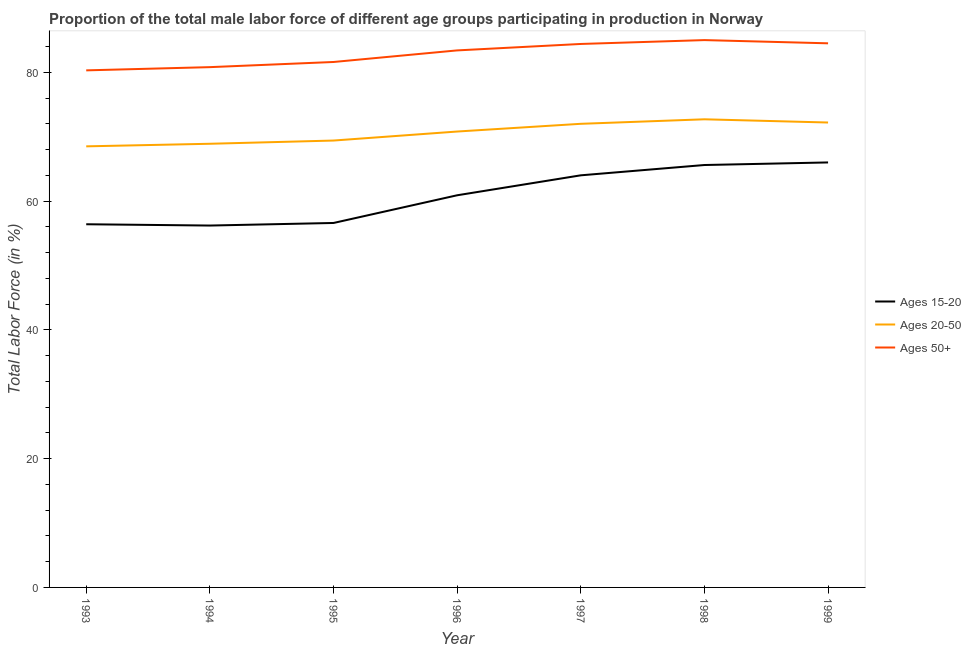How many different coloured lines are there?
Your response must be concise. 3. What is the percentage of male labor force within the age group 15-20 in 1997?
Your response must be concise. 64. Across all years, what is the maximum percentage of male labor force within the age group 20-50?
Your answer should be very brief. 72.7. Across all years, what is the minimum percentage of male labor force within the age group 15-20?
Your answer should be very brief. 56.2. In which year was the percentage of male labor force within the age group 20-50 maximum?
Give a very brief answer. 1998. What is the total percentage of male labor force within the age group 15-20 in the graph?
Keep it short and to the point. 425.7. What is the difference between the percentage of male labor force above age 50 in 1998 and that in 1999?
Offer a very short reply. 0.5. What is the difference between the percentage of male labor force above age 50 in 1993 and the percentage of male labor force within the age group 20-50 in 1998?
Keep it short and to the point. 7.6. What is the average percentage of male labor force within the age group 15-20 per year?
Make the answer very short. 60.81. In the year 1993, what is the difference between the percentage of male labor force within the age group 15-20 and percentage of male labor force within the age group 20-50?
Keep it short and to the point. -12.1. In how many years, is the percentage of male labor force within the age group 15-20 greater than 40 %?
Offer a very short reply. 7. What is the ratio of the percentage of male labor force above age 50 in 1996 to that in 1998?
Your answer should be very brief. 0.98. Is the percentage of male labor force within the age group 20-50 in 1994 less than that in 1996?
Your response must be concise. Yes. What is the difference between the highest and the second highest percentage of male labor force within the age group 20-50?
Your answer should be very brief. 0.5. What is the difference between the highest and the lowest percentage of male labor force within the age group 20-50?
Make the answer very short. 4.2. In how many years, is the percentage of male labor force within the age group 15-20 greater than the average percentage of male labor force within the age group 15-20 taken over all years?
Your answer should be compact. 4. Is the sum of the percentage of male labor force above age 50 in 1997 and 1998 greater than the maximum percentage of male labor force within the age group 20-50 across all years?
Your answer should be very brief. Yes. Is it the case that in every year, the sum of the percentage of male labor force within the age group 15-20 and percentage of male labor force within the age group 20-50 is greater than the percentage of male labor force above age 50?
Offer a terse response. Yes. What is the difference between two consecutive major ticks on the Y-axis?
Offer a terse response. 20. Does the graph contain any zero values?
Your answer should be compact. No. What is the title of the graph?
Your answer should be very brief. Proportion of the total male labor force of different age groups participating in production in Norway. Does "Machinery" appear as one of the legend labels in the graph?
Make the answer very short. No. What is the label or title of the X-axis?
Your answer should be very brief. Year. What is the Total Labor Force (in %) in Ages 15-20 in 1993?
Ensure brevity in your answer.  56.4. What is the Total Labor Force (in %) of Ages 20-50 in 1993?
Keep it short and to the point. 68.5. What is the Total Labor Force (in %) in Ages 50+ in 1993?
Offer a terse response. 80.3. What is the Total Labor Force (in %) of Ages 15-20 in 1994?
Provide a short and direct response. 56.2. What is the Total Labor Force (in %) of Ages 20-50 in 1994?
Keep it short and to the point. 68.9. What is the Total Labor Force (in %) in Ages 50+ in 1994?
Give a very brief answer. 80.8. What is the Total Labor Force (in %) in Ages 15-20 in 1995?
Keep it short and to the point. 56.6. What is the Total Labor Force (in %) in Ages 20-50 in 1995?
Your answer should be compact. 69.4. What is the Total Labor Force (in %) in Ages 50+ in 1995?
Offer a very short reply. 81.6. What is the Total Labor Force (in %) of Ages 15-20 in 1996?
Make the answer very short. 60.9. What is the Total Labor Force (in %) of Ages 20-50 in 1996?
Offer a terse response. 70.8. What is the Total Labor Force (in %) in Ages 50+ in 1996?
Offer a terse response. 83.4. What is the Total Labor Force (in %) of Ages 15-20 in 1997?
Ensure brevity in your answer.  64. What is the Total Labor Force (in %) of Ages 50+ in 1997?
Offer a terse response. 84.4. What is the Total Labor Force (in %) of Ages 15-20 in 1998?
Make the answer very short. 65.6. What is the Total Labor Force (in %) of Ages 20-50 in 1998?
Your response must be concise. 72.7. What is the Total Labor Force (in %) in Ages 20-50 in 1999?
Provide a short and direct response. 72.2. What is the Total Labor Force (in %) in Ages 50+ in 1999?
Keep it short and to the point. 84.5. Across all years, what is the maximum Total Labor Force (in %) in Ages 20-50?
Provide a short and direct response. 72.7. Across all years, what is the maximum Total Labor Force (in %) of Ages 50+?
Keep it short and to the point. 85. Across all years, what is the minimum Total Labor Force (in %) of Ages 15-20?
Provide a succinct answer. 56.2. Across all years, what is the minimum Total Labor Force (in %) in Ages 20-50?
Give a very brief answer. 68.5. Across all years, what is the minimum Total Labor Force (in %) of Ages 50+?
Your response must be concise. 80.3. What is the total Total Labor Force (in %) of Ages 15-20 in the graph?
Offer a very short reply. 425.7. What is the total Total Labor Force (in %) of Ages 20-50 in the graph?
Your answer should be compact. 494.5. What is the total Total Labor Force (in %) in Ages 50+ in the graph?
Provide a short and direct response. 580. What is the difference between the Total Labor Force (in %) of Ages 50+ in 1993 and that in 1994?
Keep it short and to the point. -0.5. What is the difference between the Total Labor Force (in %) in Ages 20-50 in 1993 and that in 1995?
Your answer should be compact. -0.9. What is the difference between the Total Labor Force (in %) in Ages 15-20 in 1993 and that in 1996?
Your answer should be compact. -4.5. What is the difference between the Total Labor Force (in %) in Ages 20-50 in 1993 and that in 1996?
Ensure brevity in your answer.  -2.3. What is the difference between the Total Labor Force (in %) of Ages 20-50 in 1993 and that in 1997?
Give a very brief answer. -3.5. What is the difference between the Total Labor Force (in %) of Ages 50+ in 1993 and that in 1997?
Provide a succinct answer. -4.1. What is the difference between the Total Labor Force (in %) of Ages 20-50 in 1993 and that in 1998?
Keep it short and to the point. -4.2. What is the difference between the Total Labor Force (in %) in Ages 50+ in 1993 and that in 1998?
Provide a succinct answer. -4.7. What is the difference between the Total Labor Force (in %) of Ages 15-20 in 1993 and that in 1999?
Give a very brief answer. -9.6. What is the difference between the Total Labor Force (in %) of Ages 50+ in 1994 and that in 1995?
Provide a short and direct response. -0.8. What is the difference between the Total Labor Force (in %) of Ages 15-20 in 1994 and that in 1996?
Ensure brevity in your answer.  -4.7. What is the difference between the Total Labor Force (in %) of Ages 20-50 in 1994 and that in 1996?
Give a very brief answer. -1.9. What is the difference between the Total Labor Force (in %) of Ages 50+ in 1994 and that in 1996?
Your answer should be very brief. -2.6. What is the difference between the Total Labor Force (in %) of Ages 15-20 in 1994 and that in 1998?
Provide a short and direct response. -9.4. What is the difference between the Total Labor Force (in %) of Ages 20-50 in 1994 and that in 1998?
Make the answer very short. -3.8. What is the difference between the Total Labor Force (in %) in Ages 15-20 in 1994 and that in 1999?
Make the answer very short. -9.8. What is the difference between the Total Labor Force (in %) in Ages 15-20 in 1995 and that in 1996?
Your answer should be very brief. -4.3. What is the difference between the Total Labor Force (in %) of Ages 50+ in 1995 and that in 1996?
Make the answer very short. -1.8. What is the difference between the Total Labor Force (in %) of Ages 20-50 in 1995 and that in 1997?
Offer a terse response. -2.6. What is the difference between the Total Labor Force (in %) of Ages 50+ in 1995 and that in 1997?
Your answer should be very brief. -2.8. What is the difference between the Total Labor Force (in %) of Ages 15-20 in 1995 and that in 1998?
Provide a short and direct response. -9. What is the difference between the Total Labor Force (in %) of Ages 20-50 in 1995 and that in 1998?
Make the answer very short. -3.3. What is the difference between the Total Labor Force (in %) of Ages 50+ in 1995 and that in 1998?
Your answer should be very brief. -3.4. What is the difference between the Total Labor Force (in %) in Ages 15-20 in 1995 and that in 1999?
Give a very brief answer. -9.4. What is the difference between the Total Labor Force (in %) of Ages 20-50 in 1995 and that in 1999?
Provide a succinct answer. -2.8. What is the difference between the Total Labor Force (in %) of Ages 50+ in 1995 and that in 1999?
Give a very brief answer. -2.9. What is the difference between the Total Labor Force (in %) of Ages 15-20 in 1996 and that in 1997?
Provide a short and direct response. -3.1. What is the difference between the Total Labor Force (in %) of Ages 50+ in 1996 and that in 1997?
Your response must be concise. -1. What is the difference between the Total Labor Force (in %) of Ages 15-20 in 1996 and that in 1998?
Keep it short and to the point. -4.7. What is the difference between the Total Labor Force (in %) in Ages 20-50 in 1996 and that in 1999?
Offer a terse response. -1.4. What is the difference between the Total Labor Force (in %) of Ages 15-20 in 1997 and that in 1998?
Keep it short and to the point. -1.6. What is the difference between the Total Labor Force (in %) in Ages 20-50 in 1997 and that in 1998?
Your response must be concise. -0.7. What is the difference between the Total Labor Force (in %) of Ages 50+ in 1997 and that in 1998?
Offer a very short reply. -0.6. What is the difference between the Total Labor Force (in %) of Ages 50+ in 1997 and that in 1999?
Keep it short and to the point. -0.1. What is the difference between the Total Labor Force (in %) of Ages 20-50 in 1998 and that in 1999?
Offer a terse response. 0.5. What is the difference between the Total Labor Force (in %) in Ages 50+ in 1998 and that in 1999?
Give a very brief answer. 0.5. What is the difference between the Total Labor Force (in %) of Ages 15-20 in 1993 and the Total Labor Force (in %) of Ages 20-50 in 1994?
Your response must be concise. -12.5. What is the difference between the Total Labor Force (in %) in Ages 15-20 in 1993 and the Total Labor Force (in %) in Ages 50+ in 1994?
Offer a very short reply. -24.4. What is the difference between the Total Labor Force (in %) in Ages 15-20 in 1993 and the Total Labor Force (in %) in Ages 20-50 in 1995?
Provide a succinct answer. -13. What is the difference between the Total Labor Force (in %) in Ages 15-20 in 1993 and the Total Labor Force (in %) in Ages 50+ in 1995?
Make the answer very short. -25.2. What is the difference between the Total Labor Force (in %) in Ages 20-50 in 1993 and the Total Labor Force (in %) in Ages 50+ in 1995?
Give a very brief answer. -13.1. What is the difference between the Total Labor Force (in %) in Ages 15-20 in 1993 and the Total Labor Force (in %) in Ages 20-50 in 1996?
Your answer should be very brief. -14.4. What is the difference between the Total Labor Force (in %) in Ages 20-50 in 1993 and the Total Labor Force (in %) in Ages 50+ in 1996?
Your response must be concise. -14.9. What is the difference between the Total Labor Force (in %) of Ages 15-20 in 1993 and the Total Labor Force (in %) of Ages 20-50 in 1997?
Make the answer very short. -15.6. What is the difference between the Total Labor Force (in %) of Ages 15-20 in 1993 and the Total Labor Force (in %) of Ages 50+ in 1997?
Make the answer very short. -28. What is the difference between the Total Labor Force (in %) of Ages 20-50 in 1993 and the Total Labor Force (in %) of Ages 50+ in 1997?
Your answer should be very brief. -15.9. What is the difference between the Total Labor Force (in %) of Ages 15-20 in 1993 and the Total Labor Force (in %) of Ages 20-50 in 1998?
Offer a very short reply. -16.3. What is the difference between the Total Labor Force (in %) of Ages 15-20 in 1993 and the Total Labor Force (in %) of Ages 50+ in 1998?
Ensure brevity in your answer.  -28.6. What is the difference between the Total Labor Force (in %) of Ages 20-50 in 1993 and the Total Labor Force (in %) of Ages 50+ in 1998?
Make the answer very short. -16.5. What is the difference between the Total Labor Force (in %) of Ages 15-20 in 1993 and the Total Labor Force (in %) of Ages 20-50 in 1999?
Offer a very short reply. -15.8. What is the difference between the Total Labor Force (in %) in Ages 15-20 in 1993 and the Total Labor Force (in %) in Ages 50+ in 1999?
Keep it short and to the point. -28.1. What is the difference between the Total Labor Force (in %) of Ages 15-20 in 1994 and the Total Labor Force (in %) of Ages 20-50 in 1995?
Ensure brevity in your answer.  -13.2. What is the difference between the Total Labor Force (in %) of Ages 15-20 in 1994 and the Total Labor Force (in %) of Ages 50+ in 1995?
Provide a short and direct response. -25.4. What is the difference between the Total Labor Force (in %) in Ages 20-50 in 1994 and the Total Labor Force (in %) in Ages 50+ in 1995?
Your answer should be very brief. -12.7. What is the difference between the Total Labor Force (in %) of Ages 15-20 in 1994 and the Total Labor Force (in %) of Ages 20-50 in 1996?
Give a very brief answer. -14.6. What is the difference between the Total Labor Force (in %) in Ages 15-20 in 1994 and the Total Labor Force (in %) in Ages 50+ in 1996?
Offer a very short reply. -27.2. What is the difference between the Total Labor Force (in %) of Ages 20-50 in 1994 and the Total Labor Force (in %) of Ages 50+ in 1996?
Your response must be concise. -14.5. What is the difference between the Total Labor Force (in %) of Ages 15-20 in 1994 and the Total Labor Force (in %) of Ages 20-50 in 1997?
Your answer should be very brief. -15.8. What is the difference between the Total Labor Force (in %) in Ages 15-20 in 1994 and the Total Labor Force (in %) in Ages 50+ in 1997?
Your answer should be very brief. -28.2. What is the difference between the Total Labor Force (in %) in Ages 20-50 in 1994 and the Total Labor Force (in %) in Ages 50+ in 1997?
Keep it short and to the point. -15.5. What is the difference between the Total Labor Force (in %) in Ages 15-20 in 1994 and the Total Labor Force (in %) in Ages 20-50 in 1998?
Ensure brevity in your answer.  -16.5. What is the difference between the Total Labor Force (in %) in Ages 15-20 in 1994 and the Total Labor Force (in %) in Ages 50+ in 1998?
Ensure brevity in your answer.  -28.8. What is the difference between the Total Labor Force (in %) in Ages 20-50 in 1994 and the Total Labor Force (in %) in Ages 50+ in 1998?
Your answer should be compact. -16.1. What is the difference between the Total Labor Force (in %) in Ages 15-20 in 1994 and the Total Labor Force (in %) in Ages 20-50 in 1999?
Make the answer very short. -16. What is the difference between the Total Labor Force (in %) of Ages 15-20 in 1994 and the Total Labor Force (in %) of Ages 50+ in 1999?
Provide a short and direct response. -28.3. What is the difference between the Total Labor Force (in %) in Ages 20-50 in 1994 and the Total Labor Force (in %) in Ages 50+ in 1999?
Your answer should be compact. -15.6. What is the difference between the Total Labor Force (in %) in Ages 15-20 in 1995 and the Total Labor Force (in %) in Ages 50+ in 1996?
Offer a very short reply. -26.8. What is the difference between the Total Labor Force (in %) in Ages 15-20 in 1995 and the Total Labor Force (in %) in Ages 20-50 in 1997?
Keep it short and to the point. -15.4. What is the difference between the Total Labor Force (in %) in Ages 15-20 in 1995 and the Total Labor Force (in %) in Ages 50+ in 1997?
Offer a very short reply. -27.8. What is the difference between the Total Labor Force (in %) in Ages 20-50 in 1995 and the Total Labor Force (in %) in Ages 50+ in 1997?
Offer a terse response. -15. What is the difference between the Total Labor Force (in %) in Ages 15-20 in 1995 and the Total Labor Force (in %) in Ages 20-50 in 1998?
Provide a short and direct response. -16.1. What is the difference between the Total Labor Force (in %) in Ages 15-20 in 1995 and the Total Labor Force (in %) in Ages 50+ in 1998?
Give a very brief answer. -28.4. What is the difference between the Total Labor Force (in %) of Ages 20-50 in 1995 and the Total Labor Force (in %) of Ages 50+ in 1998?
Keep it short and to the point. -15.6. What is the difference between the Total Labor Force (in %) of Ages 15-20 in 1995 and the Total Labor Force (in %) of Ages 20-50 in 1999?
Make the answer very short. -15.6. What is the difference between the Total Labor Force (in %) of Ages 15-20 in 1995 and the Total Labor Force (in %) of Ages 50+ in 1999?
Your response must be concise. -27.9. What is the difference between the Total Labor Force (in %) in Ages 20-50 in 1995 and the Total Labor Force (in %) in Ages 50+ in 1999?
Keep it short and to the point. -15.1. What is the difference between the Total Labor Force (in %) in Ages 15-20 in 1996 and the Total Labor Force (in %) in Ages 20-50 in 1997?
Your answer should be compact. -11.1. What is the difference between the Total Labor Force (in %) in Ages 15-20 in 1996 and the Total Labor Force (in %) in Ages 50+ in 1997?
Your answer should be very brief. -23.5. What is the difference between the Total Labor Force (in %) of Ages 15-20 in 1996 and the Total Labor Force (in %) of Ages 50+ in 1998?
Make the answer very short. -24.1. What is the difference between the Total Labor Force (in %) of Ages 20-50 in 1996 and the Total Labor Force (in %) of Ages 50+ in 1998?
Your answer should be compact. -14.2. What is the difference between the Total Labor Force (in %) of Ages 15-20 in 1996 and the Total Labor Force (in %) of Ages 50+ in 1999?
Provide a short and direct response. -23.6. What is the difference between the Total Labor Force (in %) in Ages 20-50 in 1996 and the Total Labor Force (in %) in Ages 50+ in 1999?
Your answer should be very brief. -13.7. What is the difference between the Total Labor Force (in %) in Ages 20-50 in 1997 and the Total Labor Force (in %) in Ages 50+ in 1998?
Provide a short and direct response. -13. What is the difference between the Total Labor Force (in %) in Ages 15-20 in 1997 and the Total Labor Force (in %) in Ages 20-50 in 1999?
Your answer should be very brief. -8.2. What is the difference between the Total Labor Force (in %) in Ages 15-20 in 1997 and the Total Labor Force (in %) in Ages 50+ in 1999?
Give a very brief answer. -20.5. What is the difference between the Total Labor Force (in %) in Ages 20-50 in 1997 and the Total Labor Force (in %) in Ages 50+ in 1999?
Provide a short and direct response. -12.5. What is the difference between the Total Labor Force (in %) in Ages 15-20 in 1998 and the Total Labor Force (in %) in Ages 20-50 in 1999?
Give a very brief answer. -6.6. What is the difference between the Total Labor Force (in %) in Ages 15-20 in 1998 and the Total Labor Force (in %) in Ages 50+ in 1999?
Your response must be concise. -18.9. What is the average Total Labor Force (in %) in Ages 15-20 per year?
Your answer should be very brief. 60.81. What is the average Total Labor Force (in %) of Ages 20-50 per year?
Offer a terse response. 70.64. What is the average Total Labor Force (in %) in Ages 50+ per year?
Make the answer very short. 82.86. In the year 1993, what is the difference between the Total Labor Force (in %) of Ages 15-20 and Total Labor Force (in %) of Ages 50+?
Provide a short and direct response. -23.9. In the year 1994, what is the difference between the Total Labor Force (in %) of Ages 15-20 and Total Labor Force (in %) of Ages 50+?
Ensure brevity in your answer.  -24.6. In the year 1994, what is the difference between the Total Labor Force (in %) in Ages 20-50 and Total Labor Force (in %) in Ages 50+?
Your response must be concise. -11.9. In the year 1995, what is the difference between the Total Labor Force (in %) of Ages 15-20 and Total Labor Force (in %) of Ages 20-50?
Offer a very short reply. -12.8. In the year 1995, what is the difference between the Total Labor Force (in %) of Ages 20-50 and Total Labor Force (in %) of Ages 50+?
Your answer should be very brief. -12.2. In the year 1996, what is the difference between the Total Labor Force (in %) in Ages 15-20 and Total Labor Force (in %) in Ages 50+?
Your answer should be very brief. -22.5. In the year 1996, what is the difference between the Total Labor Force (in %) in Ages 20-50 and Total Labor Force (in %) in Ages 50+?
Offer a very short reply. -12.6. In the year 1997, what is the difference between the Total Labor Force (in %) of Ages 15-20 and Total Labor Force (in %) of Ages 20-50?
Offer a terse response. -8. In the year 1997, what is the difference between the Total Labor Force (in %) of Ages 15-20 and Total Labor Force (in %) of Ages 50+?
Provide a short and direct response. -20.4. In the year 1998, what is the difference between the Total Labor Force (in %) of Ages 15-20 and Total Labor Force (in %) of Ages 20-50?
Offer a terse response. -7.1. In the year 1998, what is the difference between the Total Labor Force (in %) of Ages 15-20 and Total Labor Force (in %) of Ages 50+?
Provide a succinct answer. -19.4. In the year 1999, what is the difference between the Total Labor Force (in %) of Ages 15-20 and Total Labor Force (in %) of Ages 20-50?
Your answer should be compact. -6.2. In the year 1999, what is the difference between the Total Labor Force (in %) in Ages 15-20 and Total Labor Force (in %) in Ages 50+?
Your answer should be very brief. -18.5. What is the ratio of the Total Labor Force (in %) in Ages 15-20 in 1993 to that in 1994?
Your answer should be compact. 1. What is the ratio of the Total Labor Force (in %) in Ages 50+ in 1993 to that in 1995?
Provide a short and direct response. 0.98. What is the ratio of the Total Labor Force (in %) in Ages 15-20 in 1993 to that in 1996?
Keep it short and to the point. 0.93. What is the ratio of the Total Labor Force (in %) of Ages 20-50 in 1993 to that in 1996?
Keep it short and to the point. 0.97. What is the ratio of the Total Labor Force (in %) of Ages 50+ in 1993 to that in 1996?
Make the answer very short. 0.96. What is the ratio of the Total Labor Force (in %) of Ages 15-20 in 1993 to that in 1997?
Offer a very short reply. 0.88. What is the ratio of the Total Labor Force (in %) of Ages 20-50 in 1993 to that in 1997?
Provide a succinct answer. 0.95. What is the ratio of the Total Labor Force (in %) in Ages 50+ in 1993 to that in 1997?
Provide a succinct answer. 0.95. What is the ratio of the Total Labor Force (in %) of Ages 15-20 in 1993 to that in 1998?
Offer a terse response. 0.86. What is the ratio of the Total Labor Force (in %) of Ages 20-50 in 1993 to that in 1998?
Ensure brevity in your answer.  0.94. What is the ratio of the Total Labor Force (in %) in Ages 50+ in 1993 to that in 1998?
Your response must be concise. 0.94. What is the ratio of the Total Labor Force (in %) of Ages 15-20 in 1993 to that in 1999?
Your answer should be compact. 0.85. What is the ratio of the Total Labor Force (in %) in Ages 20-50 in 1993 to that in 1999?
Keep it short and to the point. 0.95. What is the ratio of the Total Labor Force (in %) of Ages 50+ in 1993 to that in 1999?
Ensure brevity in your answer.  0.95. What is the ratio of the Total Labor Force (in %) of Ages 50+ in 1994 to that in 1995?
Keep it short and to the point. 0.99. What is the ratio of the Total Labor Force (in %) in Ages 15-20 in 1994 to that in 1996?
Your answer should be compact. 0.92. What is the ratio of the Total Labor Force (in %) of Ages 20-50 in 1994 to that in 1996?
Your answer should be very brief. 0.97. What is the ratio of the Total Labor Force (in %) of Ages 50+ in 1994 to that in 1996?
Make the answer very short. 0.97. What is the ratio of the Total Labor Force (in %) of Ages 15-20 in 1994 to that in 1997?
Ensure brevity in your answer.  0.88. What is the ratio of the Total Labor Force (in %) in Ages 20-50 in 1994 to that in 1997?
Make the answer very short. 0.96. What is the ratio of the Total Labor Force (in %) of Ages 50+ in 1994 to that in 1997?
Give a very brief answer. 0.96. What is the ratio of the Total Labor Force (in %) of Ages 15-20 in 1994 to that in 1998?
Your answer should be compact. 0.86. What is the ratio of the Total Labor Force (in %) of Ages 20-50 in 1994 to that in 1998?
Provide a short and direct response. 0.95. What is the ratio of the Total Labor Force (in %) in Ages 50+ in 1994 to that in 1998?
Offer a very short reply. 0.95. What is the ratio of the Total Labor Force (in %) of Ages 15-20 in 1994 to that in 1999?
Offer a very short reply. 0.85. What is the ratio of the Total Labor Force (in %) in Ages 20-50 in 1994 to that in 1999?
Make the answer very short. 0.95. What is the ratio of the Total Labor Force (in %) of Ages 50+ in 1994 to that in 1999?
Your answer should be very brief. 0.96. What is the ratio of the Total Labor Force (in %) in Ages 15-20 in 1995 to that in 1996?
Provide a succinct answer. 0.93. What is the ratio of the Total Labor Force (in %) in Ages 20-50 in 1995 to that in 1996?
Make the answer very short. 0.98. What is the ratio of the Total Labor Force (in %) of Ages 50+ in 1995 to that in 1996?
Offer a very short reply. 0.98. What is the ratio of the Total Labor Force (in %) of Ages 15-20 in 1995 to that in 1997?
Your answer should be very brief. 0.88. What is the ratio of the Total Labor Force (in %) in Ages 20-50 in 1995 to that in 1997?
Ensure brevity in your answer.  0.96. What is the ratio of the Total Labor Force (in %) of Ages 50+ in 1995 to that in 1997?
Give a very brief answer. 0.97. What is the ratio of the Total Labor Force (in %) of Ages 15-20 in 1995 to that in 1998?
Keep it short and to the point. 0.86. What is the ratio of the Total Labor Force (in %) of Ages 20-50 in 1995 to that in 1998?
Keep it short and to the point. 0.95. What is the ratio of the Total Labor Force (in %) of Ages 15-20 in 1995 to that in 1999?
Give a very brief answer. 0.86. What is the ratio of the Total Labor Force (in %) of Ages 20-50 in 1995 to that in 1999?
Your answer should be compact. 0.96. What is the ratio of the Total Labor Force (in %) of Ages 50+ in 1995 to that in 1999?
Your response must be concise. 0.97. What is the ratio of the Total Labor Force (in %) in Ages 15-20 in 1996 to that in 1997?
Offer a terse response. 0.95. What is the ratio of the Total Labor Force (in %) in Ages 20-50 in 1996 to that in 1997?
Offer a very short reply. 0.98. What is the ratio of the Total Labor Force (in %) of Ages 15-20 in 1996 to that in 1998?
Provide a succinct answer. 0.93. What is the ratio of the Total Labor Force (in %) of Ages 20-50 in 1996 to that in 1998?
Your response must be concise. 0.97. What is the ratio of the Total Labor Force (in %) of Ages 50+ in 1996 to that in 1998?
Ensure brevity in your answer.  0.98. What is the ratio of the Total Labor Force (in %) in Ages 15-20 in 1996 to that in 1999?
Offer a terse response. 0.92. What is the ratio of the Total Labor Force (in %) of Ages 20-50 in 1996 to that in 1999?
Your response must be concise. 0.98. What is the ratio of the Total Labor Force (in %) of Ages 15-20 in 1997 to that in 1998?
Your answer should be compact. 0.98. What is the ratio of the Total Labor Force (in %) in Ages 20-50 in 1997 to that in 1998?
Provide a succinct answer. 0.99. What is the ratio of the Total Labor Force (in %) in Ages 50+ in 1997 to that in 1998?
Offer a very short reply. 0.99. What is the ratio of the Total Labor Force (in %) of Ages 15-20 in 1997 to that in 1999?
Ensure brevity in your answer.  0.97. What is the ratio of the Total Labor Force (in %) of Ages 20-50 in 1997 to that in 1999?
Your answer should be very brief. 1. What is the ratio of the Total Labor Force (in %) in Ages 50+ in 1997 to that in 1999?
Give a very brief answer. 1. What is the ratio of the Total Labor Force (in %) of Ages 15-20 in 1998 to that in 1999?
Offer a very short reply. 0.99. What is the ratio of the Total Labor Force (in %) of Ages 20-50 in 1998 to that in 1999?
Your answer should be compact. 1.01. What is the ratio of the Total Labor Force (in %) of Ages 50+ in 1998 to that in 1999?
Give a very brief answer. 1.01. What is the difference between the highest and the second highest Total Labor Force (in %) of Ages 15-20?
Give a very brief answer. 0.4. What is the difference between the highest and the second highest Total Labor Force (in %) in Ages 20-50?
Ensure brevity in your answer.  0.5. What is the difference between the highest and the lowest Total Labor Force (in %) of Ages 15-20?
Your answer should be very brief. 9.8. What is the difference between the highest and the lowest Total Labor Force (in %) in Ages 20-50?
Your answer should be very brief. 4.2. What is the difference between the highest and the lowest Total Labor Force (in %) in Ages 50+?
Keep it short and to the point. 4.7. 